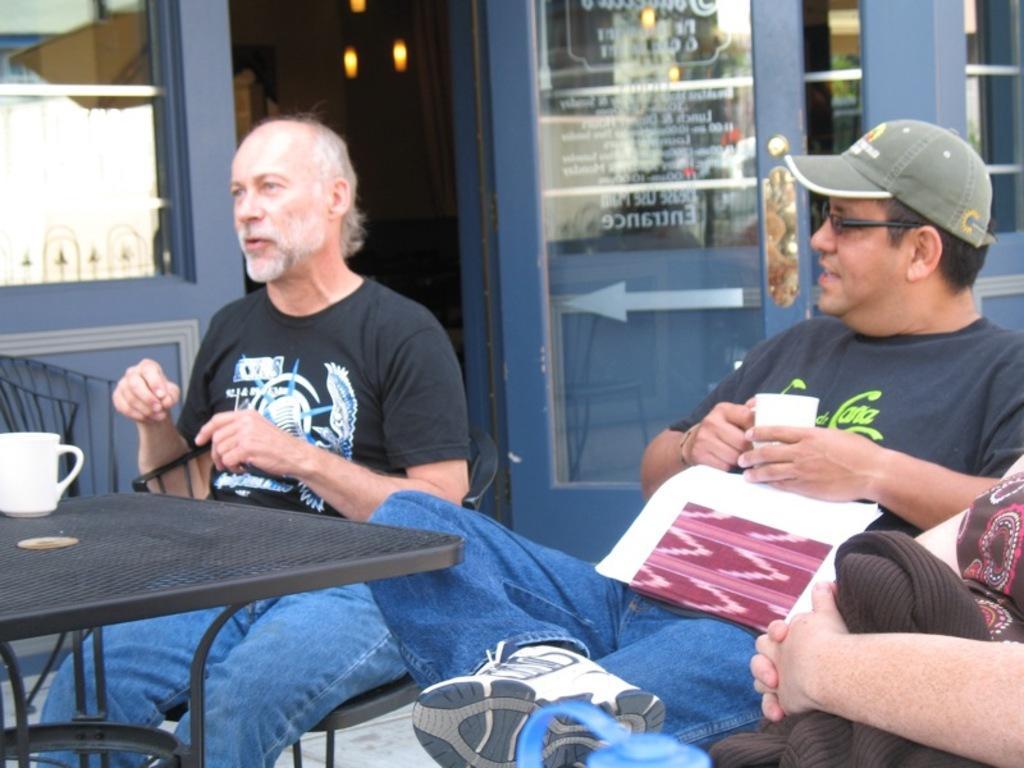Please provide a concise description of this image. Here are two persons sitting on the chairs. This is a table with a white cup placed on it. At the right corner of the image I can see a hand of the person. At background I can see a door which shows the direction,arrow mark,and this looks like a kind of restaurant. 